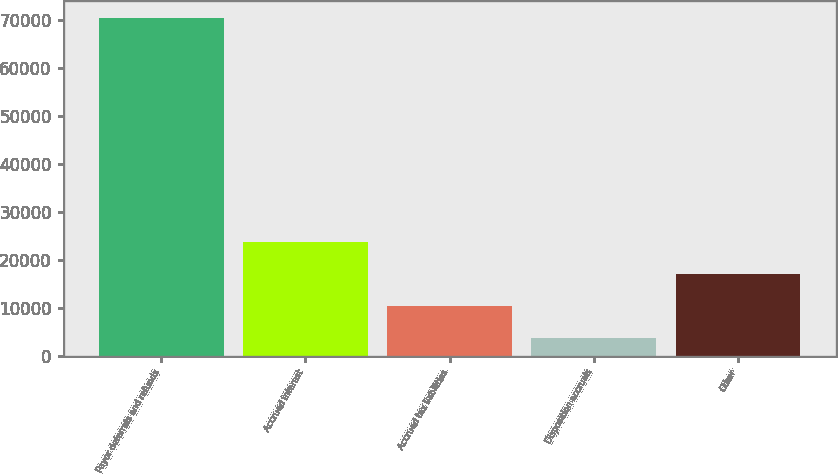Convert chart to OTSL. <chart><loc_0><loc_0><loc_500><loc_500><bar_chart><fcel>Payor deferrals and refunds<fcel>Accrued interest<fcel>Accrued tax liabilities<fcel>Disposition accruals<fcel>Other<nl><fcel>70406<fcel>23802.1<fcel>10486.7<fcel>3829<fcel>17144.4<nl></chart> 